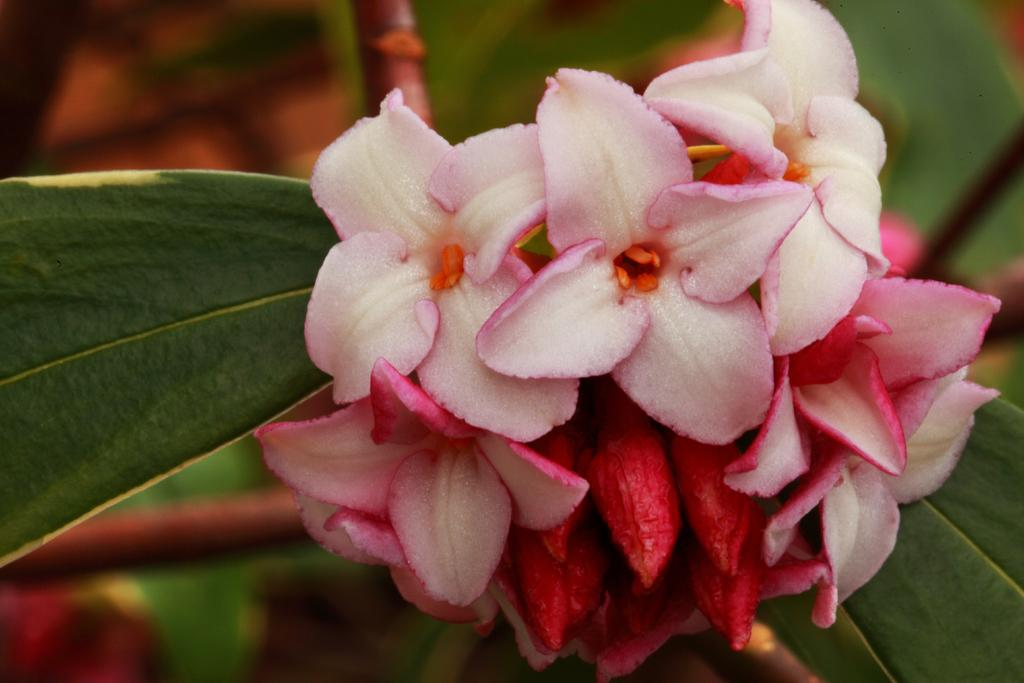What types of flowers are present in the image? There are white flowers and pink flowers in the image. Can you describe the background of the image? The background of the image is blurred. What type of box can be seen on the street in the image? There is no box or street present in the image; it features white and pink flowers with a blurred background. 